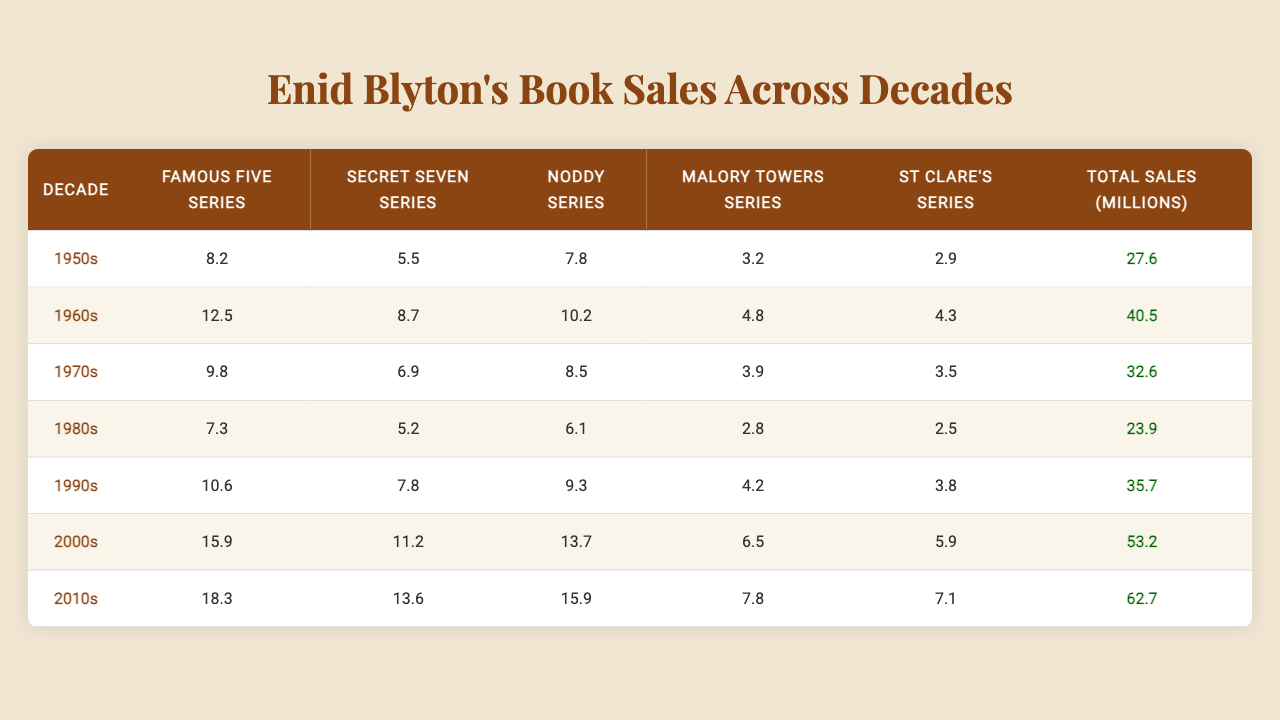What decade had the highest total sales? The total sales for each decade are provided in the last column. Upon comparison, the 2010s had the highest sales at 62.7 million.
Answer: 2010s Which series had the highest sales in the 2000s? In the 2000s, the Famous Five Series had sales of 15.9 million, which is the highest among all series for that decade.
Answer: Famous Five Series By how much did the sales of the Noddy Series increase from the 1980s to the 2000s? The Noddy Series sold 6.1 million in the 1980s and 13.7 million in the 2000s. The increase is 13.7 - 6.1 = 7.6 million.
Answer: 7.6 million What is the total sales for the Secret Seven Series across all decades? Summing the sales figures: 5.5 + 8.7 + 6.9 + 5.2 + 7.8 + 11.2 + 13.6 = 58.0 million for the Secret Seven Series.
Answer: 58.0 million In which decade did the Malory Towers Series experience its lowest sales? Looking at the sales figures for the Malory Towers Series, the lowest sales recorded were in the 1980s at 2.8 million.
Answer: 1980s What is the average sales for all series combined in the 1990s? The total sales for all series in the 1990s is 35.7 million, and there are 5 series. So, the average is 35.7 / 5 = 7.14 million.
Answer: 7.14 million Did the total sales in the 1960s exceed those in the 1970s? Yes, the total sales in the 1960s were 40.5 million, which is greater than the 32.6 million total sales in the 1970s.
Answer: Yes Which series has consistently lower sales compared to the Famous Five Series across all decades? The Secret Seven Series, Noddy Series, Malory Towers Series, and St Clare's Series all recorded lower sales than the Famous Five Series in each decade.
Answer: All of them What is the percentage increase in total sales from the 1980s to the 2010s? The total sales in the 1980s were 23.9 million and in the 2010s were 62.7 million. The increase is 62.7 - 23.9 = 38.8 million. To find the percentage increase, divide by the original amount: (38.8 / 23.9) * 100 = 162.7%.
Answer: 162.7% Which series had the highest sales in the 1950s and by how much compared to the St Clare's Series? The Famous Five Series had the highest sales in the 1950s at 8.2 million, whereas the St Clare's Series had 2.9 million. The difference is 8.2 - 2.9 = 5.3 million.
Answer: 5.3 million 